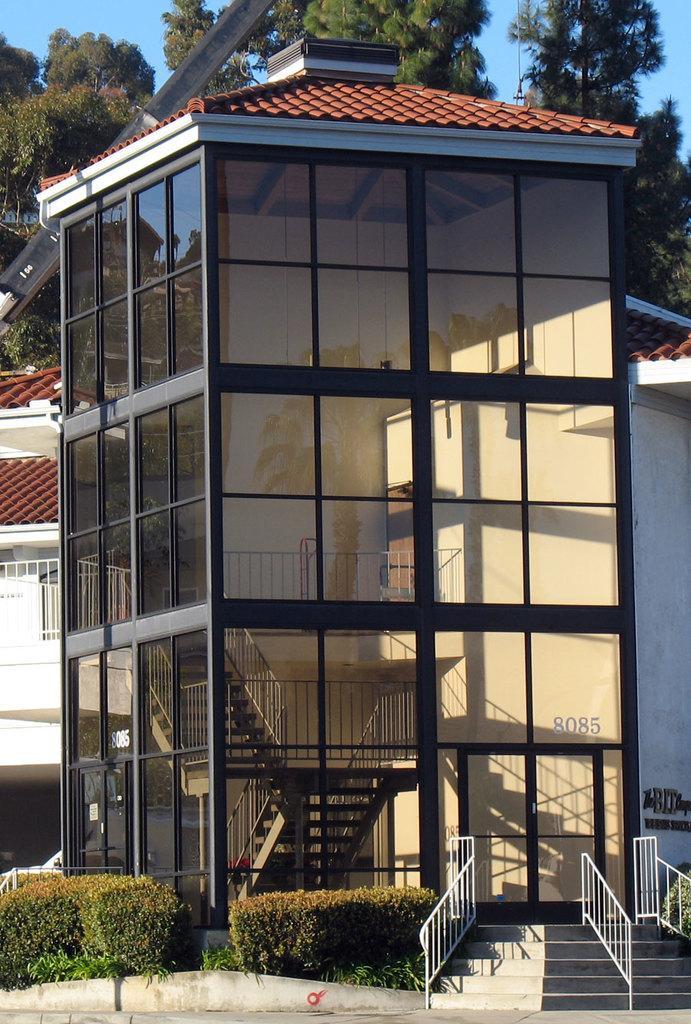Describe this image in one or two sentences. In this image I can see a building. In front of this building there are some plants and the stairs. In the background, I can see the trees. On the top of the image I can see the sky. 